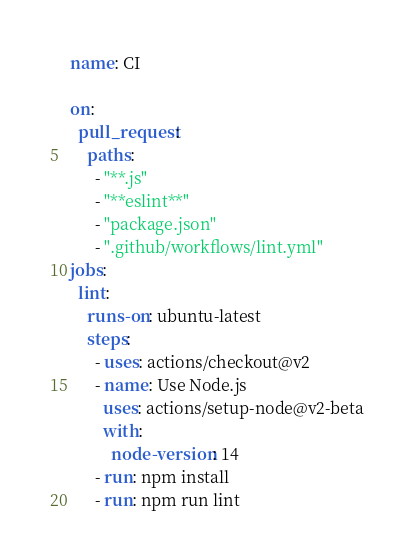<code> <loc_0><loc_0><loc_500><loc_500><_YAML_>name: CI

on:
  pull_request:
    paths:
      - "**.js"
      - "**eslint**"
      - "package.json"
      - ".github/workflows/lint.yml"
jobs:
  lint:
    runs-on: ubuntu-latest
    steps:
      - uses: actions/checkout@v2
      - name: Use Node.js
        uses: actions/setup-node@v2-beta
        with:
          node-version: 14
      - run: npm install
      - run: npm run lint
</code> 